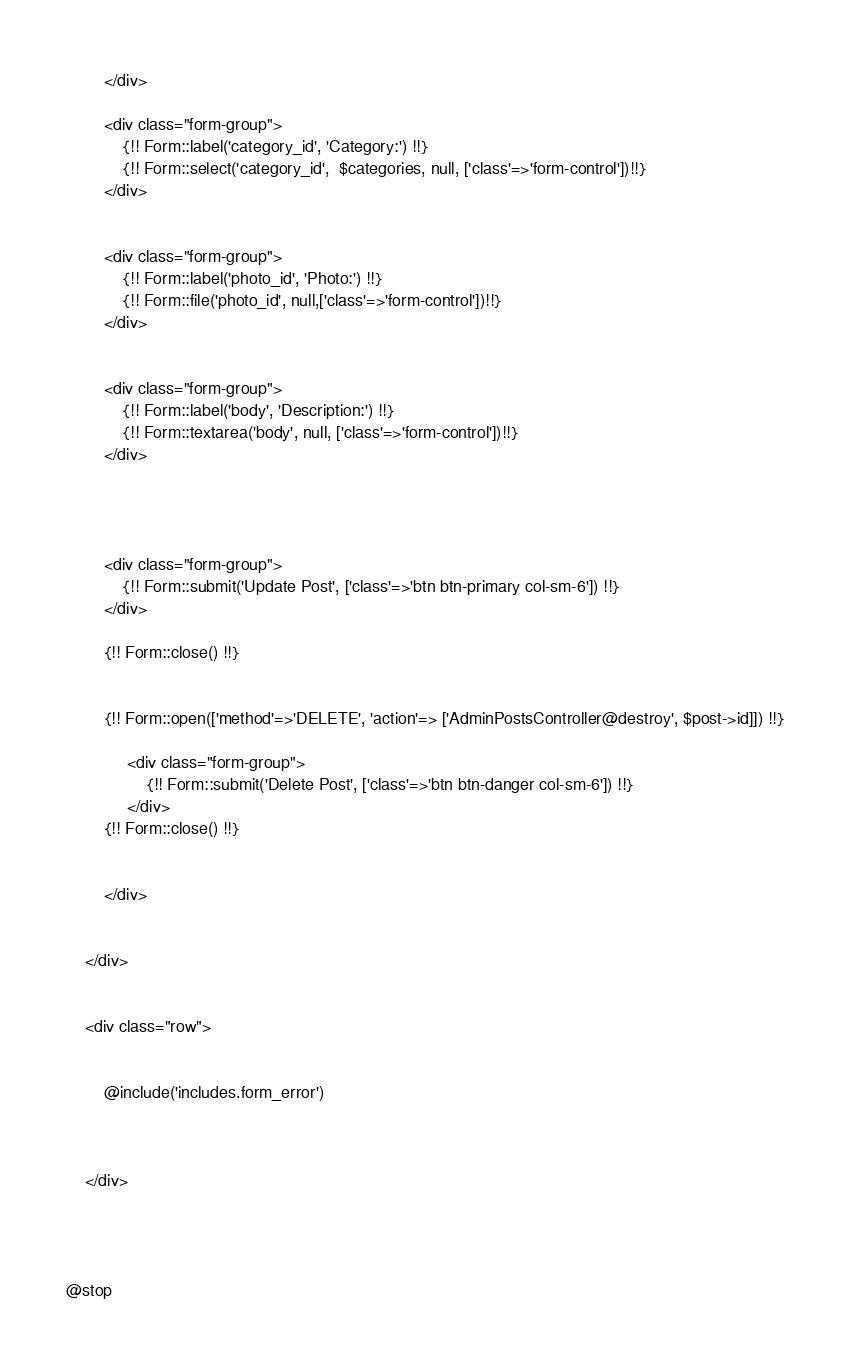Convert code to text. <code><loc_0><loc_0><loc_500><loc_500><_PHP_>        </div>

        <div class="form-group">
            {!! Form::label('category_id', 'Category:') !!}
            {!! Form::select('category_id',  $categories, null, ['class'=>'form-control'])!!}
        </div>


        <div class="form-group">
            {!! Form::label('photo_id', 'Photo:') !!}
            {!! Form::file('photo_id', null,['class'=>'form-control'])!!}
        </div>


        <div class="form-group">
            {!! Form::label('body', 'Description:') !!}
            {!! Form::textarea('body', null, ['class'=>'form-control'])!!}
        </div>




        <div class="form-group">
            {!! Form::submit('Update Post', ['class'=>'btn btn-primary col-sm-6']) !!}
        </div>

        {!! Form::close() !!}


        {!! Form::open(['method'=>'DELETE', 'action'=> ['AdminPostsController@destroy', $post->id]]) !!}

             <div class="form-group">
                 {!! Form::submit('Delete Post', ['class'=>'btn btn-danger col-sm-6']) !!}
             </div>
        {!! Form::close() !!}


        </div>


    </div>


    <div class="row">


        @include('includes.form_error')



    </div>




@stop</code> 